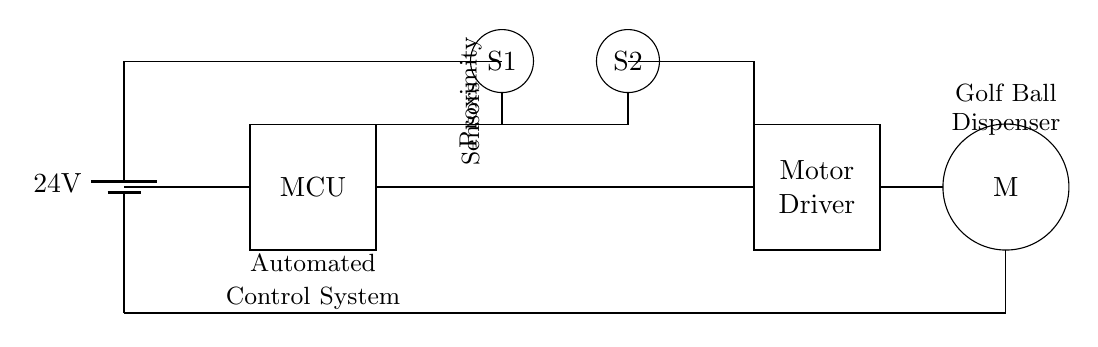What is the voltage supplied in this circuit? The circuit diagram shows a battery marked as 24V. This indicates that the voltage supply for the circuit is 24 volts.
Answer: 24 volts What is the function of the proximity sensors? The circuit contains two circles labeled as S1 and S2, which are identified as proximity sensors. Their role is to detect the presence of objects (in this case, golf balls) nearby to trigger the dispensing mechanism.
Answer: Detecting objects How many components are involved in controlling the motor? The diagram illustrates the motor driver, which is responsible for controlling the motor (M). The connection between the MCU and the motor driver facilitates the control. Thus, counting the motor driver and the DC motor, there are two components involved in controlling the operation of the motor.
Answer: Two components What type of motor is used in this system? A circle labeled "M" stands for a DC motor, which is used to dispense the golf balls. It converts electrical energy into mechanical energy for the dispensing action.
Answer: DC motor Which component receives the input signal from the sensors? The microcontroller (MCU) is positioned centrally in the diagram and connected to the proximity sensors. This indicates that the MCU receives input signals from S1 and S2, processes them, and sends commands to the motor driver.
Answer: Microcontroller How is the power supplied to the motor driver? The circuit indicates that the battery (24V) is directly connected to the motor driver, providing it power necessary for operation.
Answer: Directly from battery What is the relationship between the MCU and the proximity sensors? The diagram shows wires connecting the MCU to both proximity sensors (S1 and S2). This signifies that the MCU can read data from the sensors to determine when to activate the motor for dispensing.
Answer: Data processing relationship 